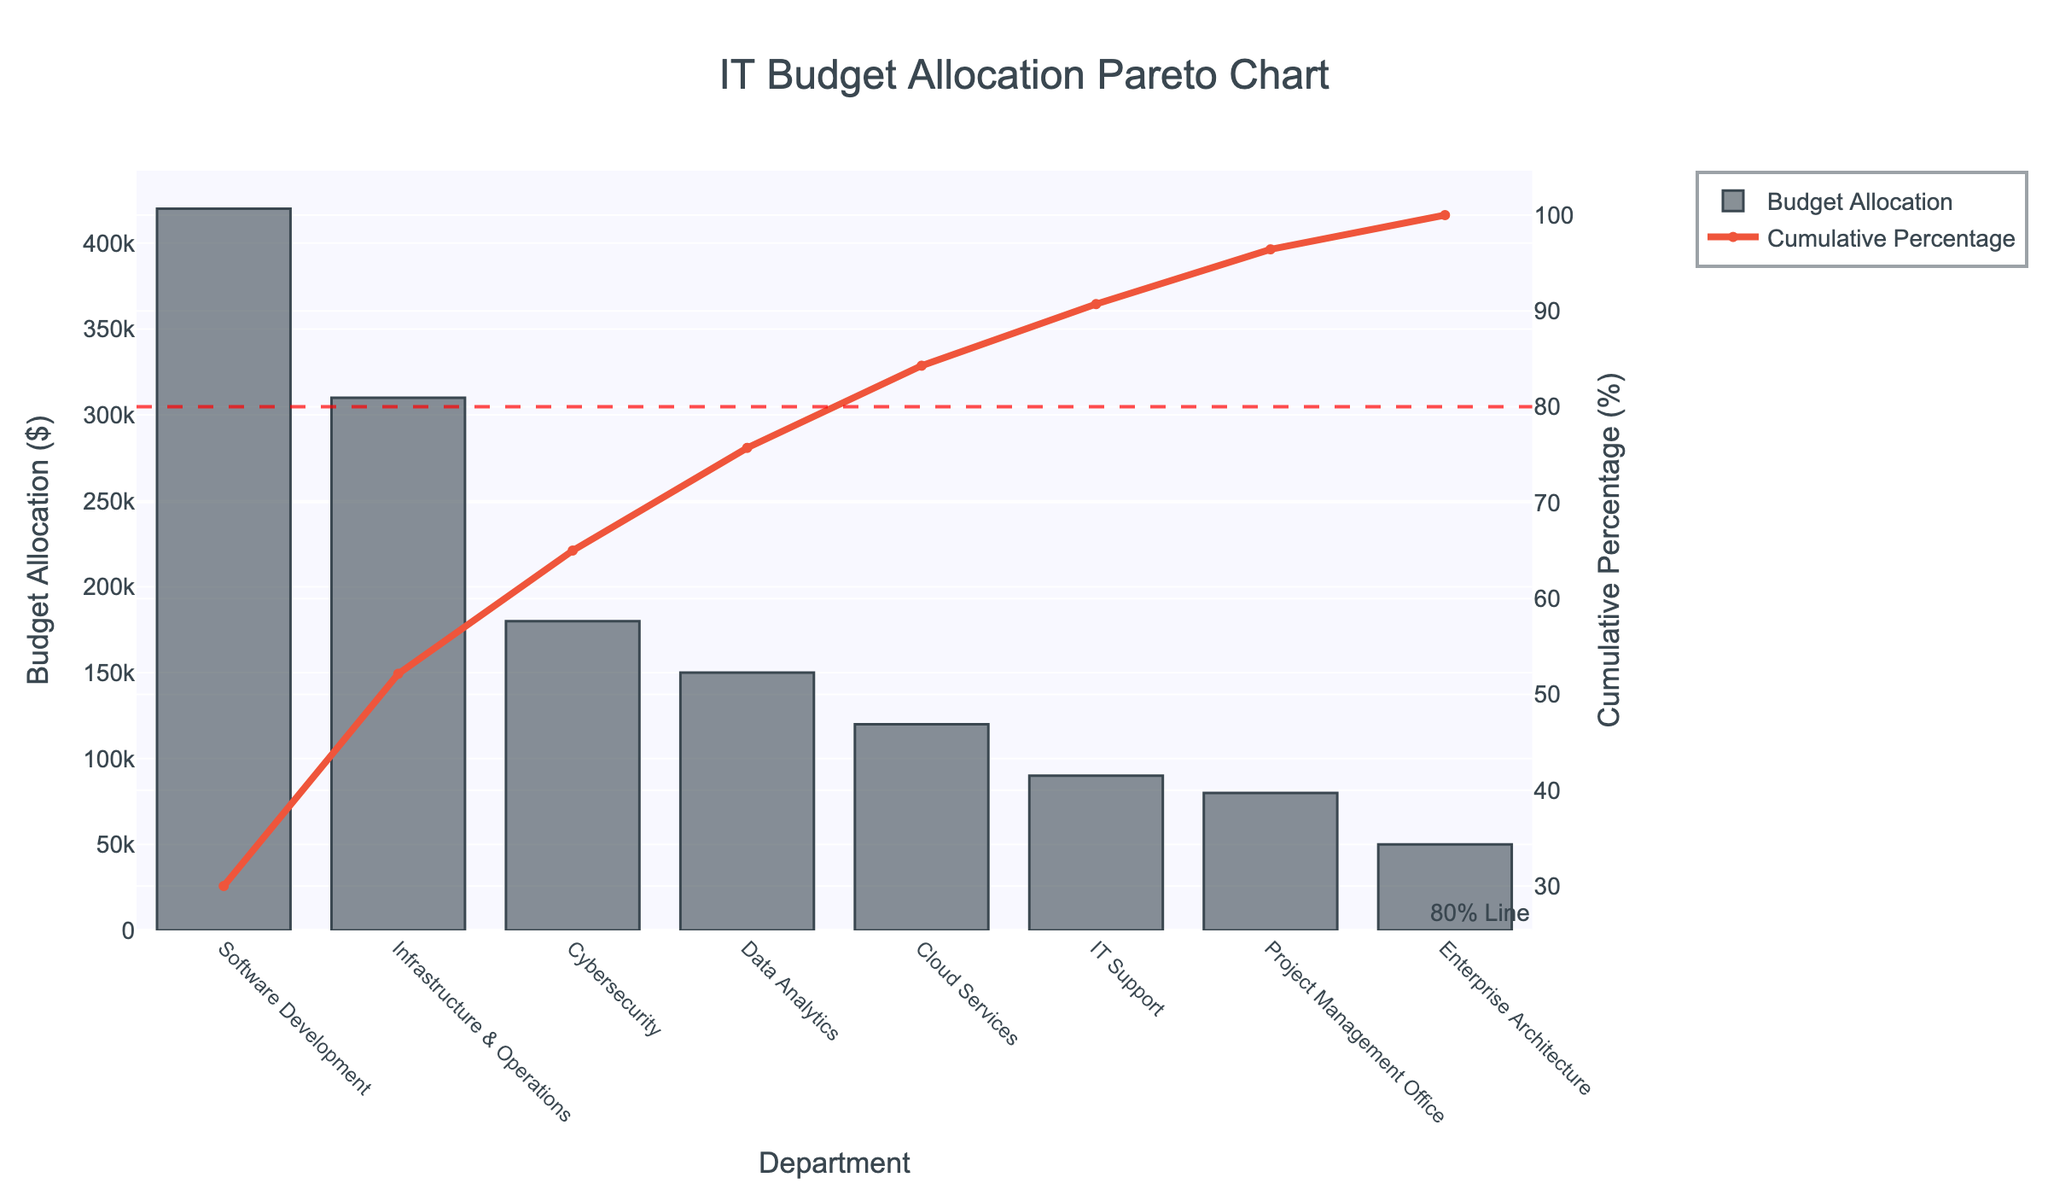What's the title of the figure? The title appears at the top of the figure. It reads "IT Budget Allocation Pareto Chart".
Answer: IT Budget Allocation Pareto Chart Which department has the highest budget allocation? In the bar chart, the tallest bar represents the department with the highest budget allocation. This is for "Software Development".
Answer: Software Development What is the cumulative percentage of budget allocation by the Cybersecurity department? Locate the Cybersecurity department on the x-axis and check its corresponding cumulative percentage on the secondary y-axis. The cumulative percentage for Cybersecurity is shown by the line chart, which is approximately 66.92%.
Answer: Approximately 66.92% How many departments are shown in the figure? Count the number of distinct departments listed on the x-axis. There are 8 departments.
Answer: 8 Which departments have budget allocations that contribute to the cumulative percentage above 80%? Find the point where the cumulative percentage line crosses the 80% reference line and list all departments before and including this point. The departments are Software Development, Infrastructure & Operations, and Cybersecurity.
Answer: Software Development, Infrastructure & Operations, Cybersecurity What is the budget allocation for the IT Support department? Identify the IT Support department on the x-axis and check the height of the corresponding bar in the primary y-axis, which indicates a budget allocation of $90,000.
Answer: $90,000 What is the total budget allocated for Cloud Services and Project Management Office? Add the budget allocations for Cloud Services ($120,000) and Project Management Office ($80,000). The sum is $200,000.
Answer: $200,000 How much more budget is allocated to Software Development compared to Data Analytics? Subtract the budget allocation for Data Analytics ($150,000) from the budget allocation for Software Development ($420,000). The difference is $270,000.
Answer: $270,000 What is the cumulative percentage right after Data Analytics? Locate Data Analytics on the x-axis and find the cumulative percentage point right after it on the secondary y-axis. This should be just below 77.89%.
Answer: Just below 77.89% Which department's budget allocation is closest to $50,000? Identify the bar whose height is closest to the $50,000 mark on the primary y-axis. This corresponds to the Enterprise Architecture department.
Answer: Enterprise Architecture 